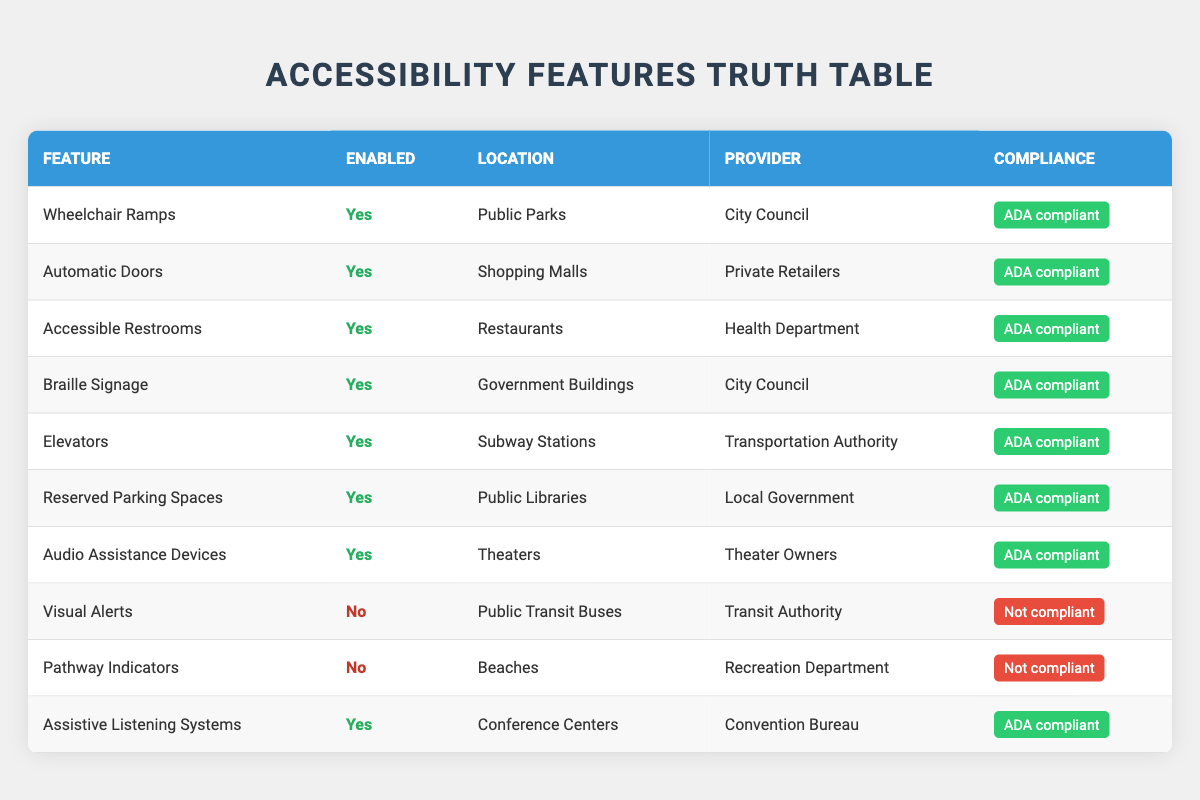What accessibility feature is provided at public libraries? The table shows that "Reserved Parking Spaces" is the accessibility feature provided at public libraries, with it being enabled and compliant with ADA regulations.
Answer: Reserved Parking Spaces How many features are compliant with the ADA? By reviewing the table, we can count the features marked as "ADA compliant". These are: Wheelchair Ramps, Automatic Doors, Accessible Restrooms, Braille Signage, Elevators, Reserved Parking Spaces, Audio Assistance Devices, and Assistive Listening Systems totaling 8.
Answer: 8 Are Visual Alerts enabled in public transit buses? The table states that Visual Alerts are disabled for public transit buses, indicating that they are not an available feature at that location.
Answer: No What location has the feature with the highest number of enabled accessibility features? Examining the table, we notice that many locations have enabled features, but "Public Libraries" is identified as having its feature "Reserved Parking Spaces" enabled, while other locations like subway stations and theaters have one each. All enabled features are listed in separate locations, so no location stands out as having multiple enabled features.
Answer: No location has multiple enabled features Is there any location without an enabled accessibility feature? By inspecting the table, it is clear that all listed locations have at least one feature enabled, but "Visual Alerts" and "Pathway Indicators" are specifically noted as being disabled and not available in their respective locations. Hence, there are still locations that do not have enabled features.
Answer: Yes 